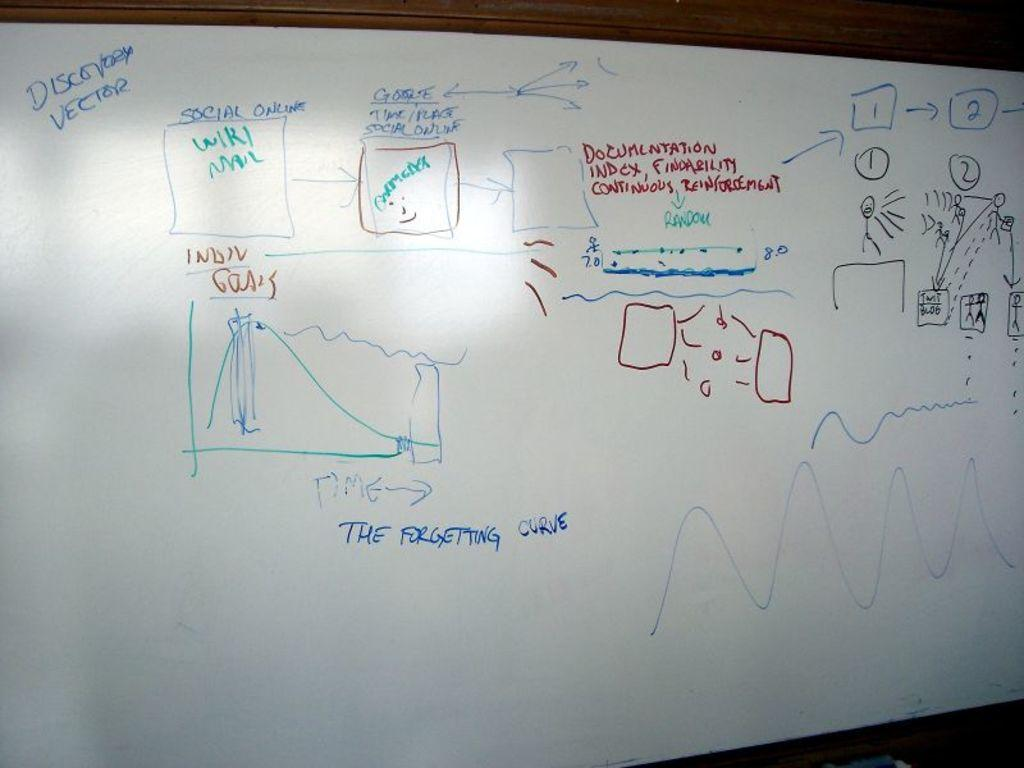<image>
Render a clear and concise summary of the photo. A whiteboard is partially covered with phrases like "The Forgetting Curve" as well as numbers and crude drawings. 